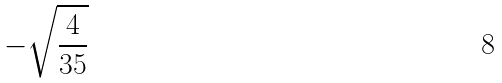Convert formula to latex. <formula><loc_0><loc_0><loc_500><loc_500>- \sqrt { \frac { 4 } { 3 5 } }</formula> 